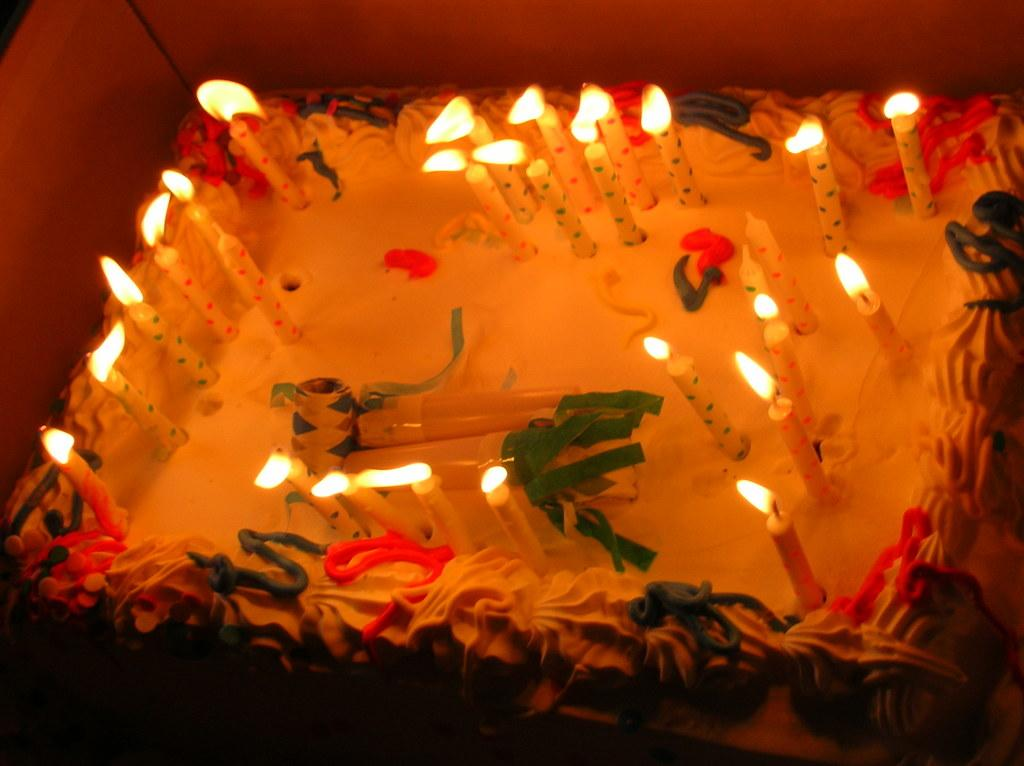What is the main object in the image? There is a cake in the image. What is placed on top of the cake? There are candles on the cake. What type of underwear is visible on the cake in the image? There is no underwear present on the cake in the image. 